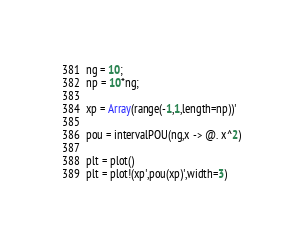<code> <loc_0><loc_0><loc_500><loc_500><_Julia_>ng = 10;
np = 10*ng;

xp = Array(range(-1,1,length=np))'

pou = intervalPOU(ng,x -> @. x^2)

plt = plot()
plt = plot!(xp',pou(xp)',width=3)

</code> 